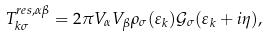Convert formula to latex. <formula><loc_0><loc_0><loc_500><loc_500>T ^ { r e s , \alpha \beta } _ { k \sigma } = 2 \pi V _ { \alpha } V _ { \beta } \rho _ { \sigma } ( \varepsilon _ { k } ) \mathcal { G } _ { \sigma } ( \varepsilon _ { k } + i \eta ) ,</formula> 